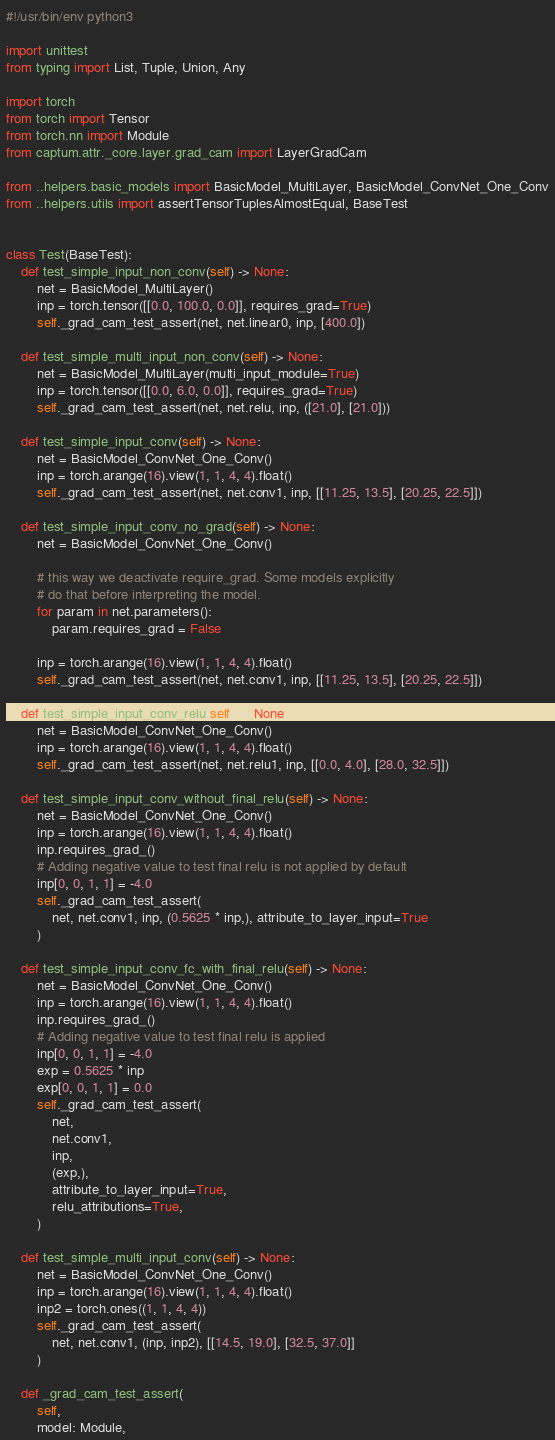Convert code to text. <code><loc_0><loc_0><loc_500><loc_500><_Python_>#!/usr/bin/env python3

import unittest
from typing import List, Tuple, Union, Any

import torch
from torch import Tensor
from torch.nn import Module
from captum.attr._core.layer.grad_cam import LayerGradCam

from ..helpers.basic_models import BasicModel_MultiLayer, BasicModel_ConvNet_One_Conv
from ..helpers.utils import assertTensorTuplesAlmostEqual, BaseTest


class Test(BaseTest):
    def test_simple_input_non_conv(self) -> None:
        net = BasicModel_MultiLayer()
        inp = torch.tensor([[0.0, 100.0, 0.0]], requires_grad=True)
        self._grad_cam_test_assert(net, net.linear0, inp, [400.0])

    def test_simple_multi_input_non_conv(self) -> None:
        net = BasicModel_MultiLayer(multi_input_module=True)
        inp = torch.tensor([[0.0, 6.0, 0.0]], requires_grad=True)
        self._grad_cam_test_assert(net, net.relu, inp, ([21.0], [21.0]))

    def test_simple_input_conv(self) -> None:
        net = BasicModel_ConvNet_One_Conv()
        inp = torch.arange(16).view(1, 1, 4, 4).float()
        self._grad_cam_test_assert(net, net.conv1, inp, [[11.25, 13.5], [20.25, 22.5]])

    def test_simple_input_conv_no_grad(self) -> None:
        net = BasicModel_ConvNet_One_Conv()

        # this way we deactivate require_grad. Some models explicitly
        # do that before interpreting the model.
        for param in net.parameters():
            param.requires_grad = False

        inp = torch.arange(16).view(1, 1, 4, 4).float()
        self._grad_cam_test_assert(net, net.conv1, inp, [[11.25, 13.5], [20.25, 22.5]])

    def test_simple_input_conv_relu(self) -> None:
        net = BasicModel_ConvNet_One_Conv()
        inp = torch.arange(16).view(1, 1, 4, 4).float()
        self._grad_cam_test_assert(net, net.relu1, inp, [[0.0, 4.0], [28.0, 32.5]])

    def test_simple_input_conv_without_final_relu(self) -> None:
        net = BasicModel_ConvNet_One_Conv()
        inp = torch.arange(16).view(1, 1, 4, 4).float()
        inp.requires_grad_()
        # Adding negative value to test final relu is not applied by default
        inp[0, 0, 1, 1] = -4.0
        self._grad_cam_test_assert(
            net, net.conv1, inp, (0.5625 * inp,), attribute_to_layer_input=True
        )

    def test_simple_input_conv_fc_with_final_relu(self) -> None:
        net = BasicModel_ConvNet_One_Conv()
        inp = torch.arange(16).view(1, 1, 4, 4).float()
        inp.requires_grad_()
        # Adding negative value to test final relu is applied
        inp[0, 0, 1, 1] = -4.0
        exp = 0.5625 * inp
        exp[0, 0, 1, 1] = 0.0
        self._grad_cam_test_assert(
            net,
            net.conv1,
            inp,
            (exp,),
            attribute_to_layer_input=True,
            relu_attributions=True,
        )

    def test_simple_multi_input_conv(self) -> None:
        net = BasicModel_ConvNet_One_Conv()
        inp = torch.arange(16).view(1, 1, 4, 4).float()
        inp2 = torch.ones((1, 1, 4, 4))
        self._grad_cam_test_assert(
            net, net.conv1, (inp, inp2), [[14.5, 19.0], [32.5, 37.0]]
        )

    def _grad_cam_test_assert(
        self,
        model: Module,</code> 